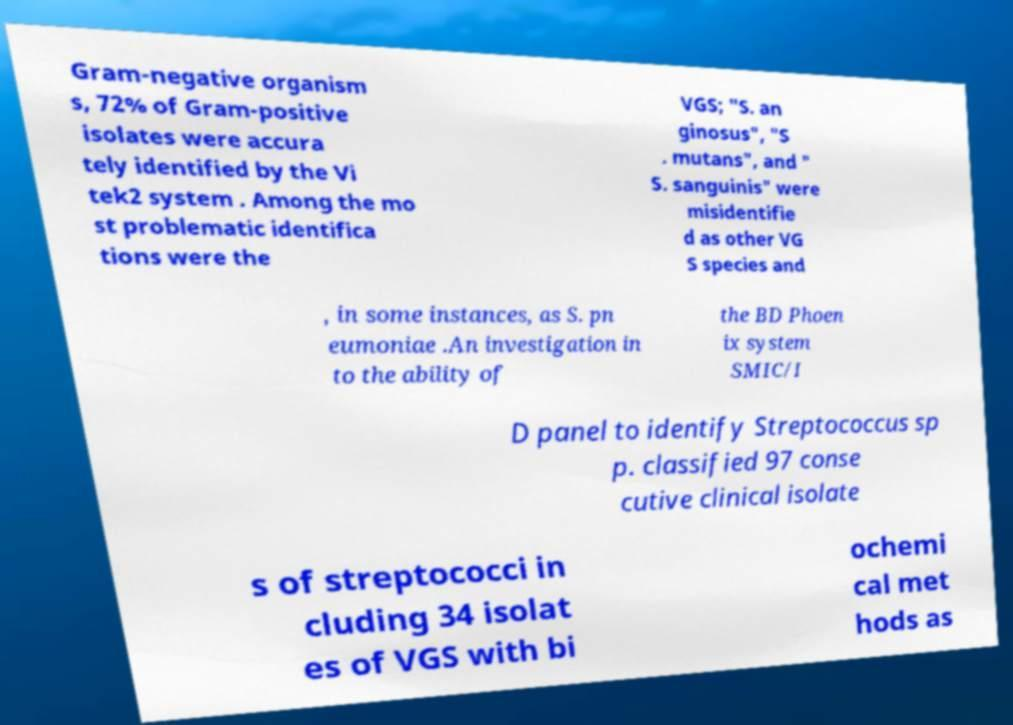Can you read and provide the text displayed in the image?This photo seems to have some interesting text. Can you extract and type it out for me? Gram-negative organism s, 72% of Gram-positive isolates were accura tely identified by the Vi tek2 system . Among the mo st problematic identifica tions were the VGS; "S. an ginosus", "S . mutans", and " S. sanguinis" were misidentifie d as other VG S species and , in some instances, as S. pn eumoniae .An investigation in to the ability of the BD Phoen ix system SMIC/I D panel to identify Streptococcus sp p. classified 97 conse cutive clinical isolate s of streptococci in cluding 34 isolat es of VGS with bi ochemi cal met hods as 